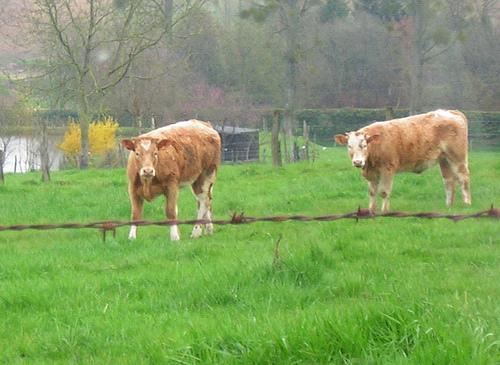How many cows are there?
Give a very brief answer. 2. 